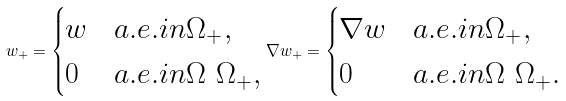<formula> <loc_0><loc_0><loc_500><loc_500>w _ { + } = \begin{cases} w & a . e . i n \Omega _ { + } , \\ 0 & a . e . i n \Omega \ \Omega _ { + } , \end{cases} \nabla w _ { + } = \begin{cases} \nabla w & a . e . i n \Omega _ { + } , \\ 0 & a . e . i n \Omega \ \Omega _ { + } . \end{cases}</formula> 